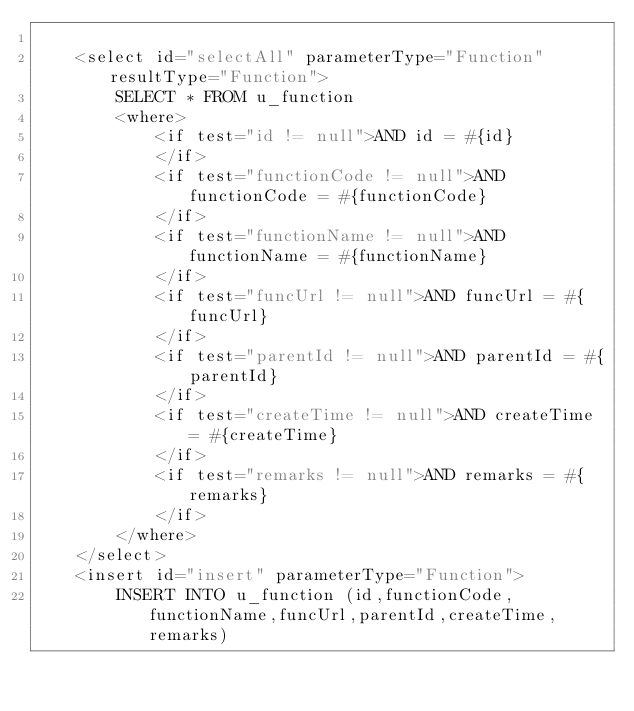<code> <loc_0><loc_0><loc_500><loc_500><_XML_>	
	<select id="selectAll" parameterType="Function" resultType="Function">
		SELECT * FROM u_function
		<where>
			<if test="id != null">AND id = #{id}
			</if>
			<if test="functionCode != null">AND functionCode = #{functionCode}
			</if>
			<if test="functionName != null">AND functionName = #{functionName}
			</if>
			<if test="funcUrl != null">AND funcUrl = #{funcUrl}
			</if>
			<if test="parentId != null">AND parentId = #{parentId}
			</if>
			<if test="createTime != null">AND createTime = #{createTime}
			</if>
			<if test="remarks != null">AND remarks = #{remarks}
			</if>
		</where>
	</select>
	<insert id="insert" parameterType="Function">
		INSERT INTO u_function (id,functionCode,functionName,funcUrl,parentId,createTime,remarks)</code> 